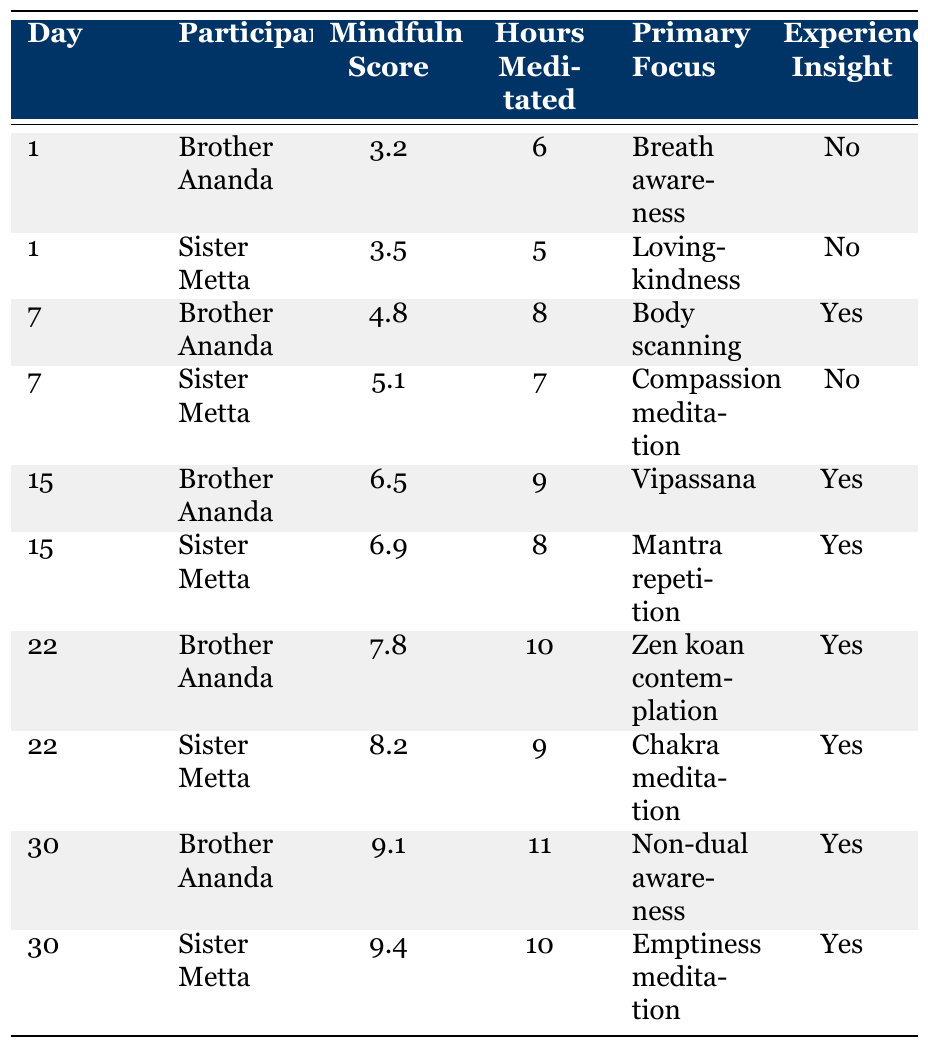What was Brother Ananda's mindfulness score on Day 1? According to the table, Brother Ananda's mindfulness score on Day 1 is listed as 3.2.
Answer: 3.2 What was the primary focus of Sister Metta on Day 15? The table indicates that Sister Metta's primary focus on Day 15 was "Mantra repetition."
Answer: Mantra repetition How many hours did Sister Metta meditate on Day 30? Sister Metta's meditation hours on Day 30 are given as 10 in the table.
Answer: 10 Which participant had the highest mindfulness score overall? By comparing the mindfulness scores, Sister Metta had the highest score at 9.4 on Day 30.
Answer: Sister Metta What was the total number of hours meditated by Brother Ananda across all days? Brother Ananda's meditation hours are 6 + 8 + 9 + 10 + 11 = 44 across all specified days.
Answer: 44 Did Sister Metta experience insight on Day 1? The table shows that Sister Metta did not experience insight on Day 1, as indicated by "No."
Answer: No What percentage of days did Brother Ananda experience insight? Brother Ananda experienced insight on Days 7, 15, 22, and 30, which are 4 out of 5 days. Therefore, the percentage is (4/5) * 100 = 80%.
Answer: 80% On which day did both participants achieve a mindfulness score above 8? The table shows that on Day 22 and Day 30, both participants had mindfulness scores above 8.
Answer: Day 22 and Day 30 What was the difference in mindfulness scores between Sister Metta on Day 22 and Brother Ananda on Day 15? Sister Metta's score on Day 22 was 8.2 while Brother Ananda's score on Day 15 was 6.5, leading to a difference of 8.2 - 6.5 = 1.7.
Answer: 1.7 What primary focus did Brother Ananda adopt on the last day of the retreat? The table specifies that on Day 30, Brother Ananda focused on "Non-dual awareness."
Answer: Non-dual awareness 